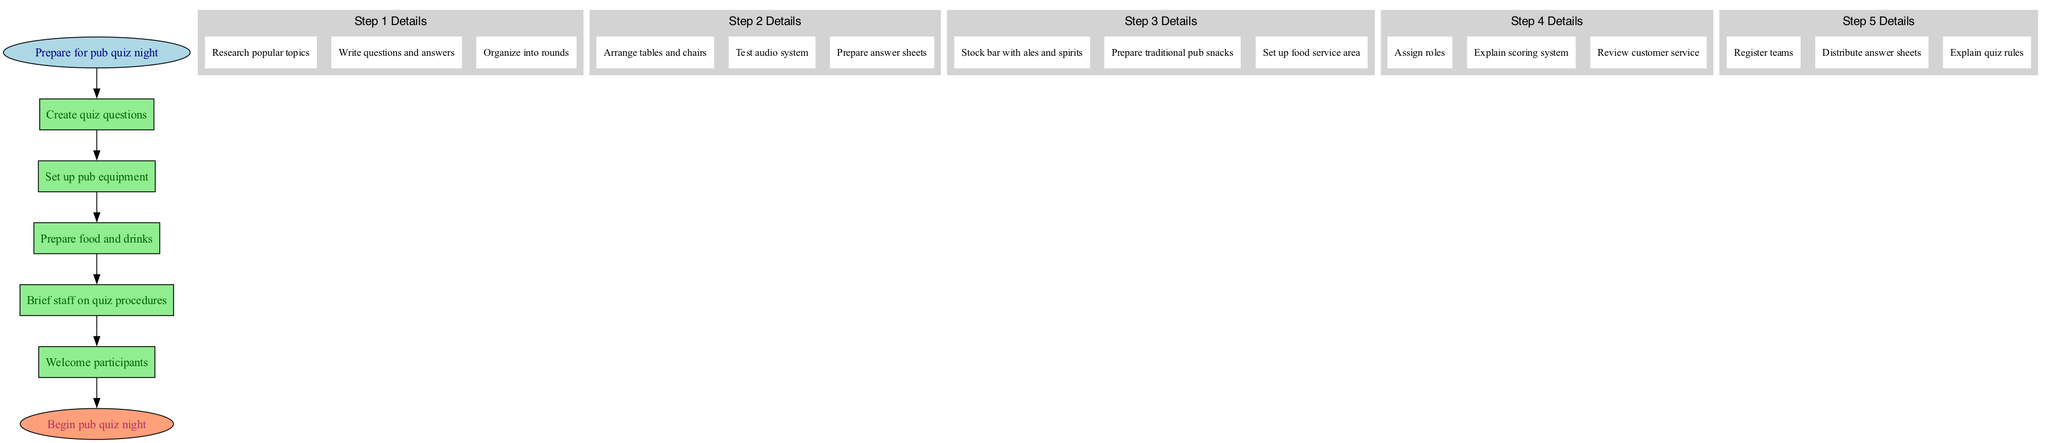What is the first step in the quiz setup? The first step in the quiz setup is shown at the top of the diagram, labeled 'Prepare for pub quiz night.' This is the beginning of the flow, leading to the subsequent steps.
Answer: Prepare for pub quiz night How many main steps are there in the process? The diagram displays five main steps in the pub quiz setup process, each visually represented in boxes labeled from one to five.
Answer: Five What is the last step before the quiz begins? The last step before the quiz begins is indicated in a box labeled 'Welcome participants,' which leads to the end of the process represented by the ellipse.
Answer: Welcome participants What are the sub-steps for creating quiz questions? The sub-steps for creating quiz questions are displayed within the first step's cluster, specifically labeled as: 'Research popular topics,' 'Write questions and answers,' and 'Organize into rounds.'
Answer: Research popular topics, Write questions and answers, Organize into rounds How does the food preparation step relate to participant welcoming? The food preparation step is shown as the third step in the diagram, while participant welcoming is the fifth. The structure indicates the food preparation must occur before welcoming participants, illustrating the sequence of events leading to the quiz night.
Answer: Food preparation must occur before welcoming participants 